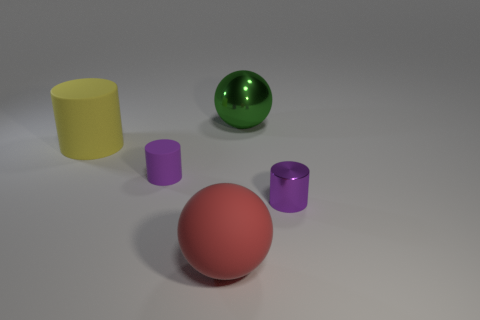What is the size of the shiny object that is the same shape as the yellow rubber thing?
Keep it short and to the point. Small. Do the matte sphere and the green shiny sphere have the same size?
Keep it short and to the point. Yes. There is another big rubber object that is the same shape as the green object; what is its color?
Provide a succinct answer. Red. How many small things have the same color as the small metal cylinder?
Your response must be concise. 1. Are there more things that are behind the red ball than tiny green objects?
Your answer should be very brief. Yes. The rubber thing that is in front of the small cylinder that is to the left of the big green shiny sphere is what color?
Your answer should be compact. Red. What number of things are green shiny spheres that are to the right of the big red ball or matte objects that are on the left side of the red object?
Offer a very short reply. 3. The shiny sphere has what color?
Your response must be concise. Green. What number of other things have the same material as the big green thing?
Give a very brief answer. 1. Are there more green metal things than tiny purple cylinders?
Give a very brief answer. No. 